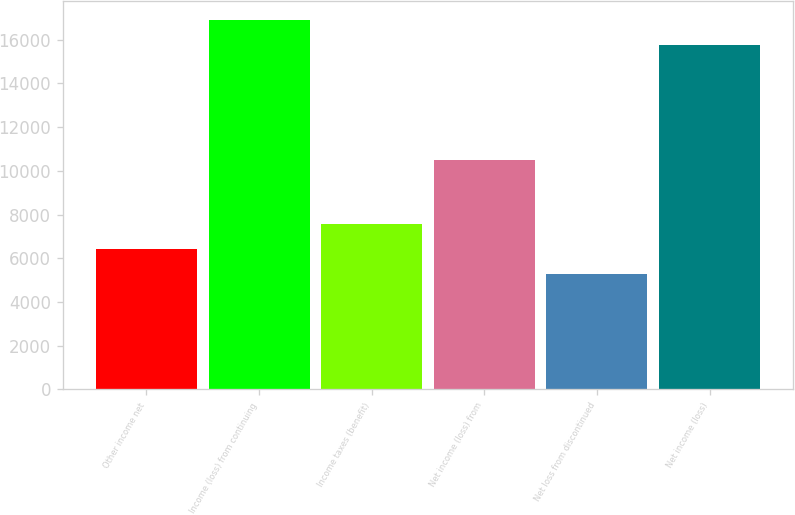Convert chart. <chart><loc_0><loc_0><loc_500><loc_500><bar_chart><fcel>Other income net<fcel>Income (loss) from continuing<fcel>Income taxes (benefit)<fcel>Net income (loss) from<fcel>Net loss from discontinued<fcel>Net income (loss)<nl><fcel>6432.7<fcel>16907.7<fcel>7589.4<fcel>10475<fcel>5276<fcel>15751<nl></chart> 